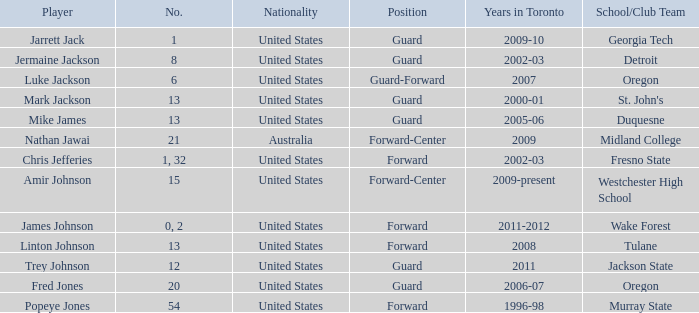Who are all of the players on the Westchester High School club team? Amir Johnson. Would you mind parsing the complete table? {'header': ['Player', 'No.', 'Nationality', 'Position', 'Years in Toronto', 'School/Club Team'], 'rows': [['Jarrett Jack', '1', 'United States', 'Guard', '2009-10', 'Georgia Tech'], ['Jermaine Jackson', '8', 'United States', 'Guard', '2002-03', 'Detroit'], ['Luke Jackson', '6', 'United States', 'Guard-Forward', '2007', 'Oregon'], ['Mark Jackson', '13', 'United States', 'Guard', '2000-01', "St. John's"], ['Mike James', '13', 'United States', 'Guard', '2005-06', 'Duquesne'], ['Nathan Jawai', '21', 'Australia', 'Forward-Center', '2009', 'Midland College'], ['Chris Jefferies', '1, 32', 'United States', 'Forward', '2002-03', 'Fresno State'], ['Amir Johnson', '15', 'United States', 'Forward-Center', '2009-present', 'Westchester High School'], ['James Johnson', '0, 2', 'United States', 'Forward', '2011-2012', 'Wake Forest'], ['Linton Johnson', '13', 'United States', 'Forward', '2008', 'Tulane'], ['Trey Johnson', '12', 'United States', 'Guard', '2011', 'Jackson State'], ['Fred Jones', '20', 'United States', 'Guard', '2006-07', 'Oregon'], ['Popeye Jones', '54', 'United States', 'Forward', '1996-98', 'Murray State']]} 